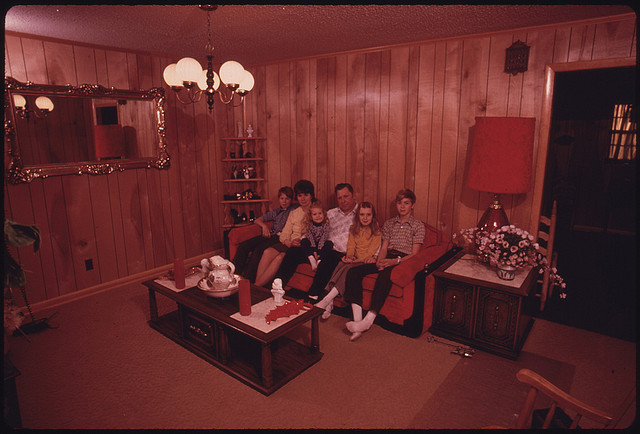<image>Are these heat lamps? I don't know if these are heat lamps. However, the consensus appears to be 'no'. Are these heat lamps? I don't know if these are heat lamps. It seems like they are not. 